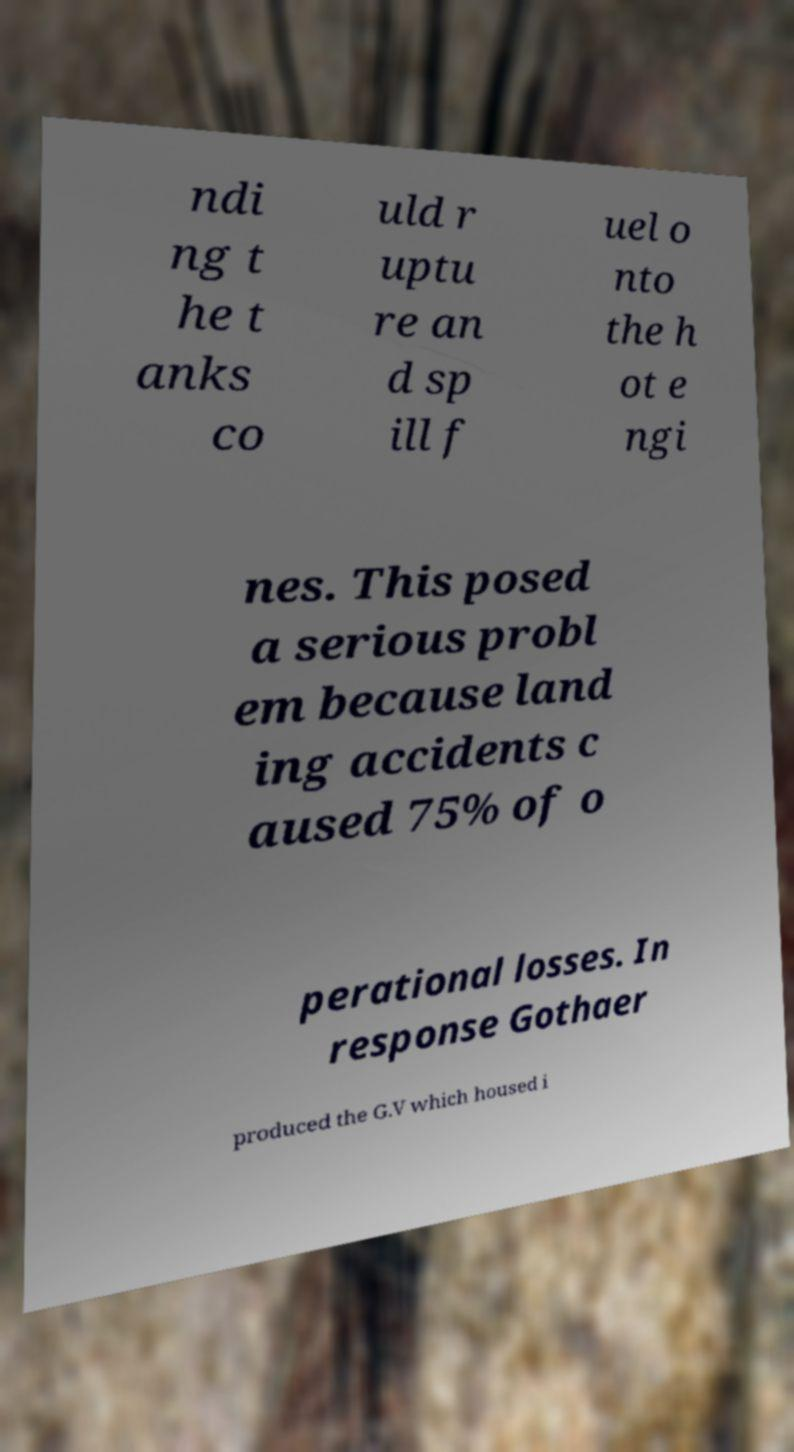Could you extract and type out the text from this image? ndi ng t he t anks co uld r uptu re an d sp ill f uel o nto the h ot e ngi nes. This posed a serious probl em because land ing accidents c aused 75% of o perational losses. In response Gothaer produced the G.V which housed i 